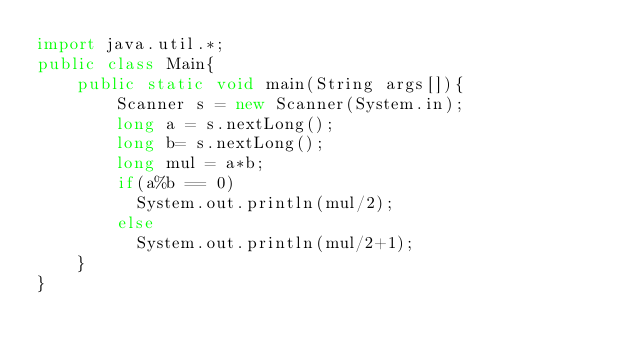<code> <loc_0><loc_0><loc_500><loc_500><_Java_>import java.util.*;
public class Main{
	public static void main(String args[]){
    	Scanner s = new Scanner(System.in);
      	long a = s.nextLong();
      	long b= s.nextLong();
      	long mul = a*b;
      	if(a%b == 0)
          System.out.println(mul/2);
      	else
          System.out.println(mul/2+1);
    }
}</code> 